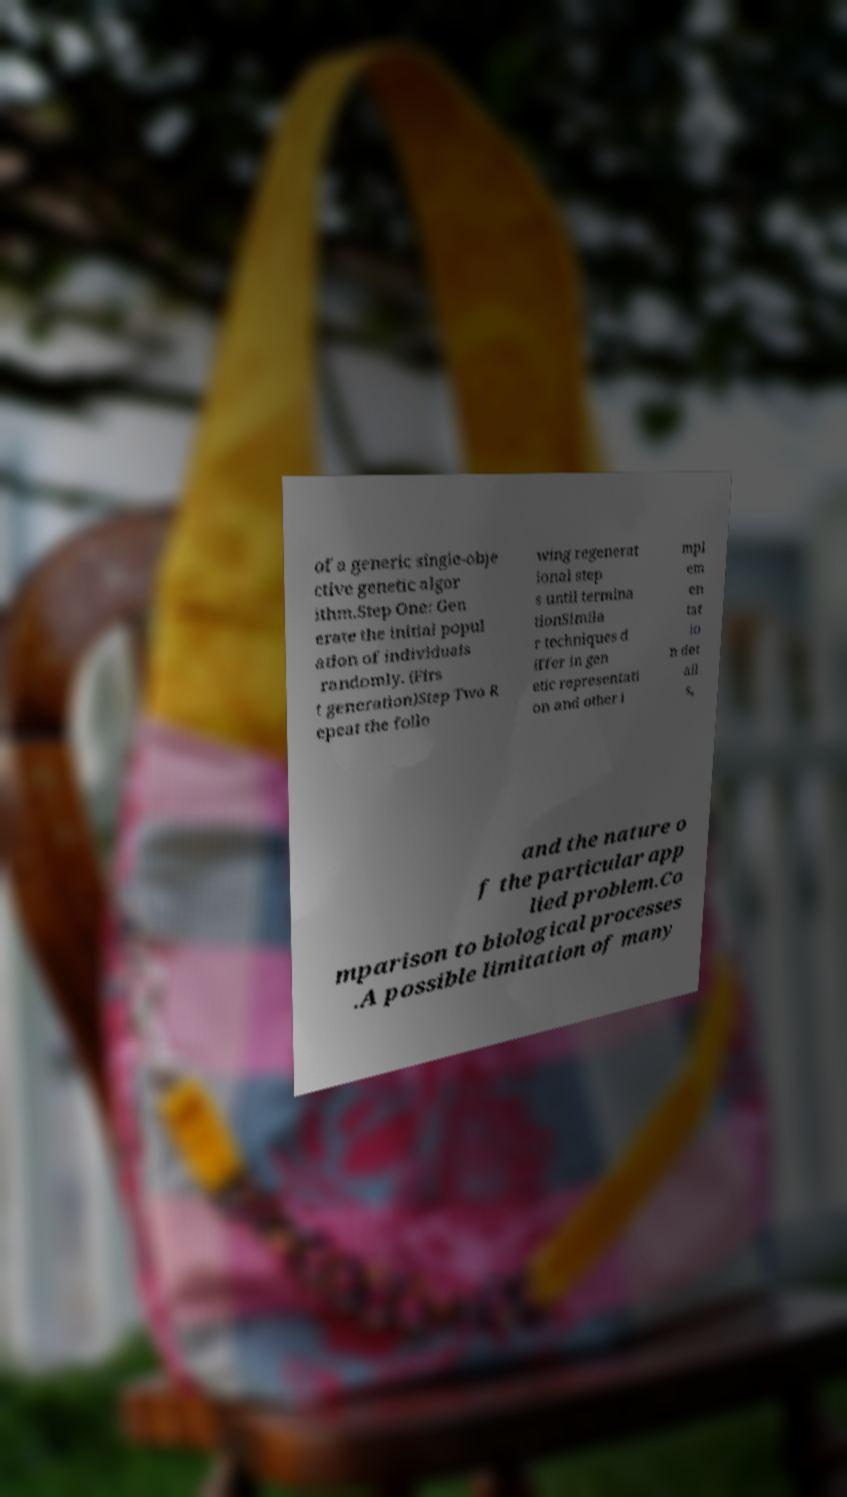Please read and relay the text visible in this image. What does it say? of a generic single-obje ctive genetic algor ithm.Step One: Gen erate the initial popul ation of individuals randomly. (Firs t generation)Step Two R epeat the follo wing regenerat ional step s until termina tionSimila r techniques d iffer in gen etic representati on and other i mpl em en tat io n det ail s, and the nature o f the particular app lied problem.Co mparison to biological processes .A possible limitation of many 